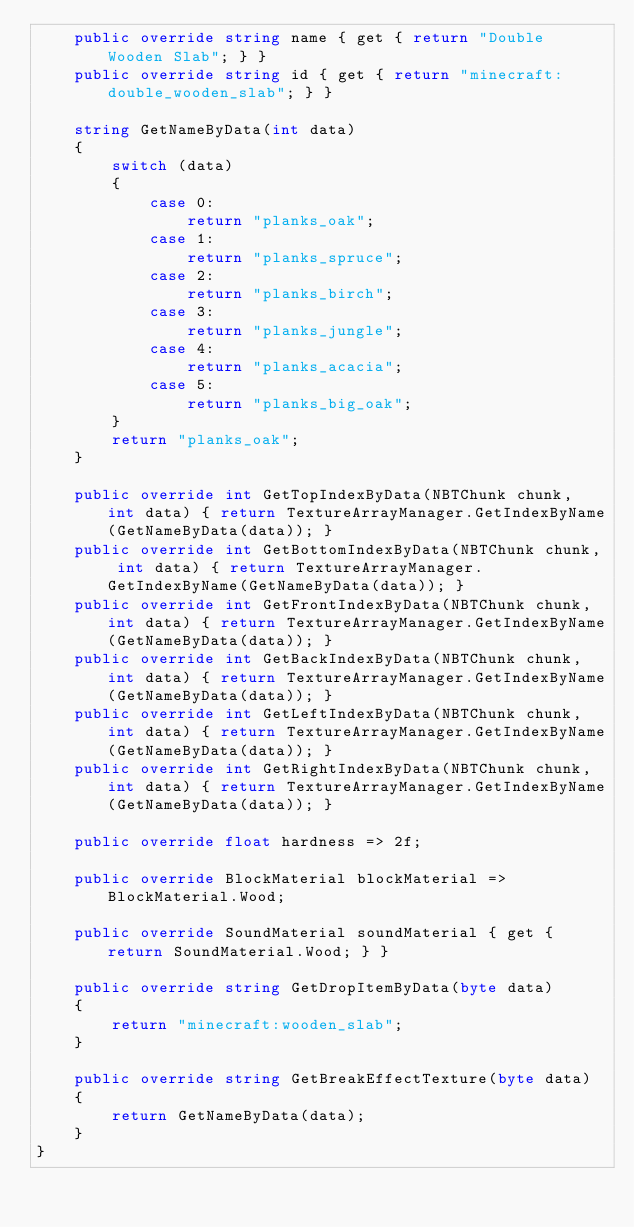<code> <loc_0><loc_0><loc_500><loc_500><_C#_>    public override string name { get { return "Double Wooden Slab"; } }
    public override string id { get { return "minecraft:double_wooden_slab"; } }

    string GetNameByData(int data)
    {
        switch (data)
        {
            case 0:
                return "planks_oak";
            case 1:
                return "planks_spruce";
            case 2:
                return "planks_birch";
            case 3:
                return "planks_jungle";
            case 4:
                return "planks_acacia";
            case 5:
                return "planks_big_oak";
        }
        return "planks_oak";
    }

    public override int GetTopIndexByData(NBTChunk chunk, int data) { return TextureArrayManager.GetIndexByName(GetNameByData(data)); }
    public override int GetBottomIndexByData(NBTChunk chunk, int data) { return TextureArrayManager.GetIndexByName(GetNameByData(data)); }
    public override int GetFrontIndexByData(NBTChunk chunk, int data) { return TextureArrayManager.GetIndexByName(GetNameByData(data)); }
    public override int GetBackIndexByData(NBTChunk chunk, int data) { return TextureArrayManager.GetIndexByName(GetNameByData(data)); }
    public override int GetLeftIndexByData(NBTChunk chunk, int data) { return TextureArrayManager.GetIndexByName(GetNameByData(data)); }
    public override int GetRightIndexByData(NBTChunk chunk, int data) { return TextureArrayManager.GetIndexByName(GetNameByData(data)); }

    public override float hardness => 2f;

    public override BlockMaterial blockMaterial => BlockMaterial.Wood;

    public override SoundMaterial soundMaterial { get { return SoundMaterial.Wood; } }

    public override string GetDropItemByData(byte data)
    {
        return "minecraft:wooden_slab";
    }

    public override string GetBreakEffectTexture(byte data)
    {
        return GetNameByData(data);
    }
}
</code> 